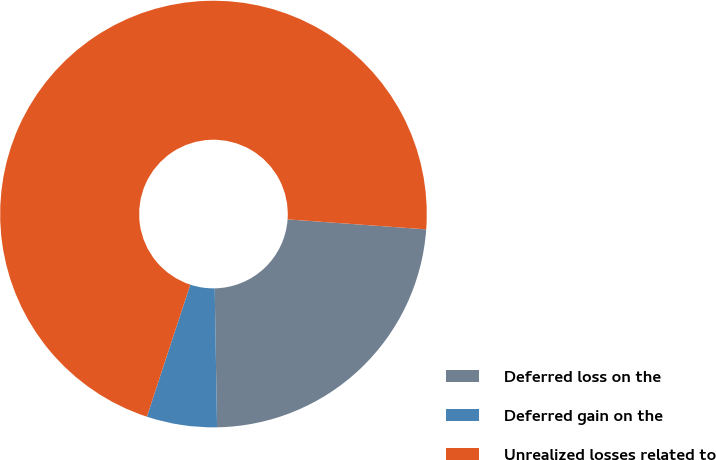<chart> <loc_0><loc_0><loc_500><loc_500><pie_chart><fcel>Deferred loss on the<fcel>Deferred gain on the<fcel>Unrealized losses related to<nl><fcel>23.59%<fcel>5.32%<fcel>71.09%<nl></chart> 